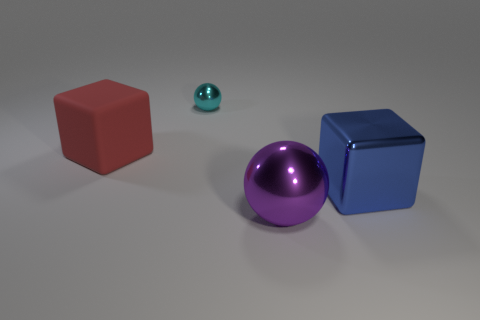Are there any patterns or textual elements in the image? The image is devoid of any explicit patterns or text. It focuses solely on the geometric objects and their material properties, leaving the background and surrounding space clear and unadorned. Could you describe the layout of the objects? Certainly! The objects are organized in a staggered formation on a flat surface. From left to right, there is a large red cube, then a small teal sphere slightly in the background, followed by a large purple sphere, and lastly, a large blue cube on the right. The arrangement provides a clear view of each object, highlighting their colors and material qualities. 